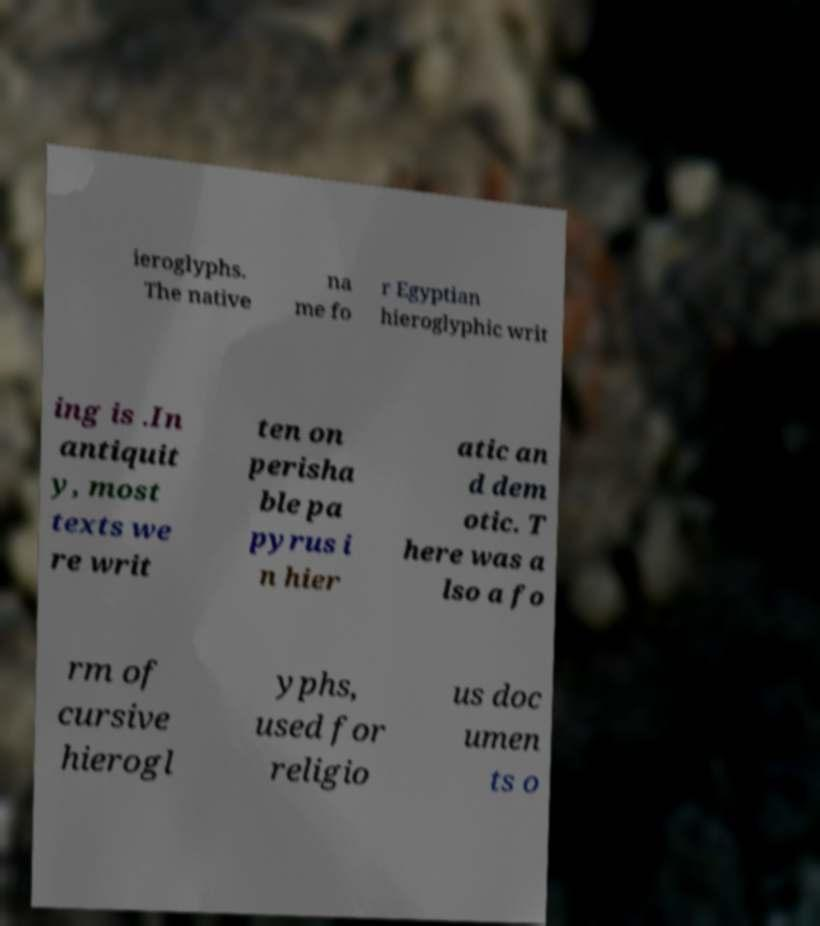Can you read and provide the text displayed in the image?This photo seems to have some interesting text. Can you extract and type it out for me? ieroglyphs. The native na me fo r Egyptian hieroglyphic writ ing is .In antiquit y, most texts we re writ ten on perisha ble pa pyrus i n hier atic an d dem otic. T here was a lso a fo rm of cursive hierogl yphs, used for religio us doc umen ts o 